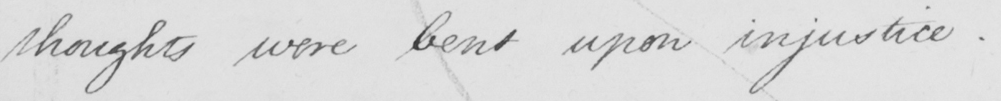Can you tell me what this handwritten text says? thoughts were bent upon injustice . _ 